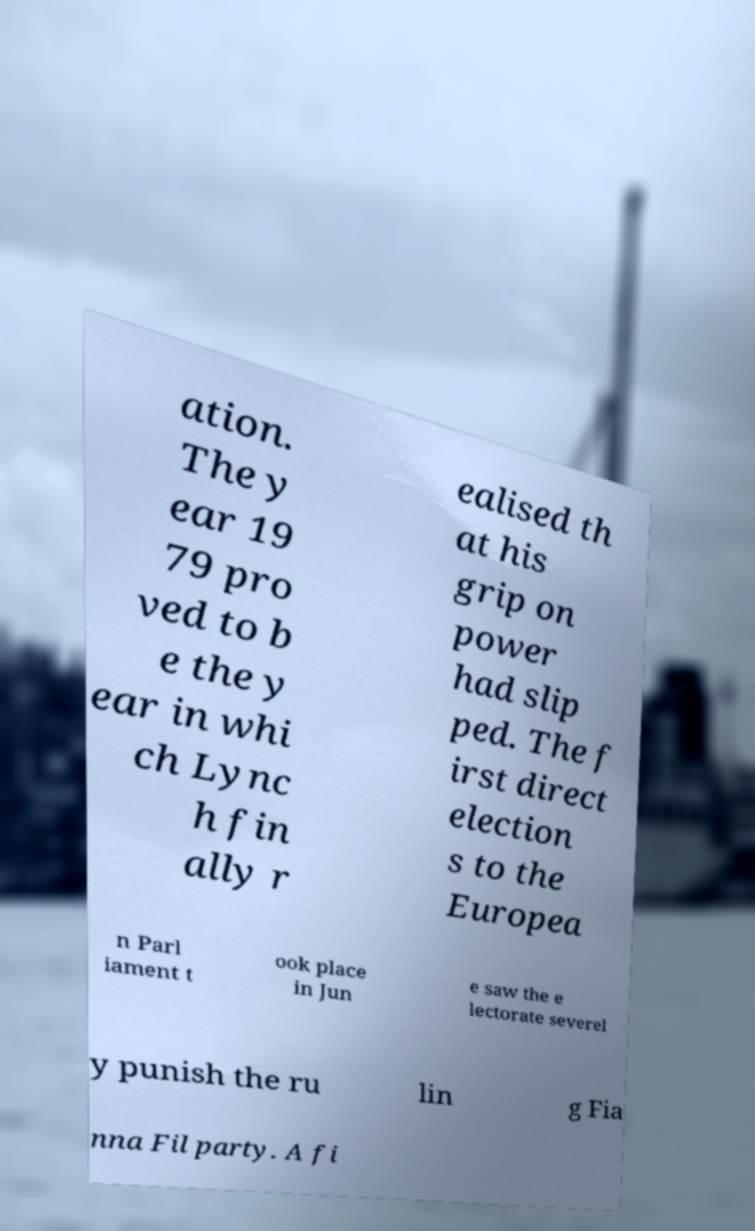What messages or text are displayed in this image? I need them in a readable, typed format. ation. The y ear 19 79 pro ved to b e the y ear in whi ch Lync h fin ally r ealised th at his grip on power had slip ped. The f irst direct election s to the Europea n Parl iament t ook place in Jun e saw the e lectorate severel y punish the ru lin g Fia nna Fil party. A fi 